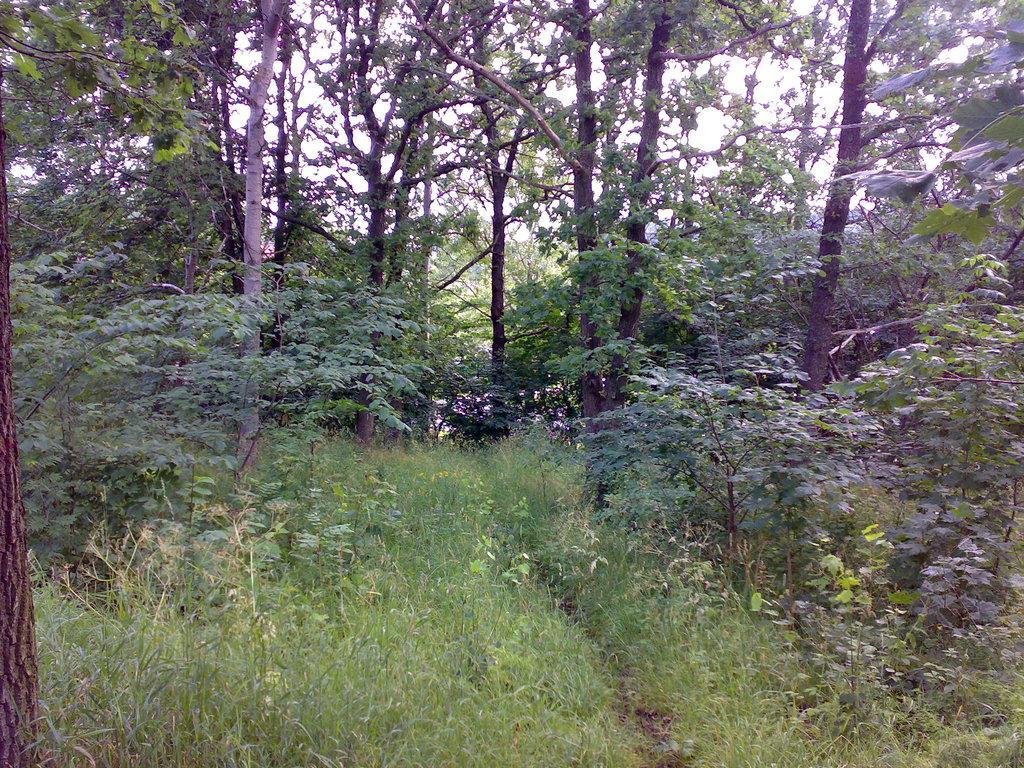Could you give a brief overview of what you see in this image? This is the picture of a forest. In this image there are trees. At the top there is sky. At the bottom there is grass. 